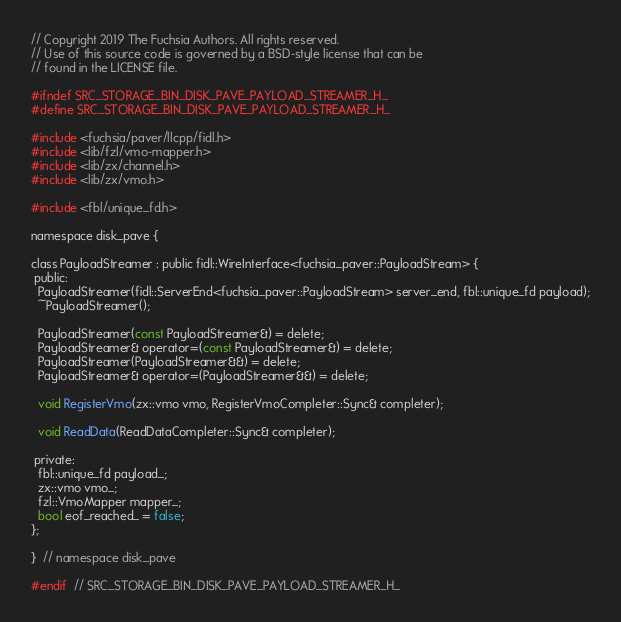<code> <loc_0><loc_0><loc_500><loc_500><_C_>// Copyright 2019 The Fuchsia Authors. All rights reserved.
// Use of this source code is governed by a BSD-style license that can be
// found in the LICENSE file.

#ifndef SRC_STORAGE_BIN_DISK_PAVE_PAYLOAD_STREAMER_H_
#define SRC_STORAGE_BIN_DISK_PAVE_PAYLOAD_STREAMER_H_

#include <fuchsia/paver/llcpp/fidl.h>
#include <lib/fzl/vmo-mapper.h>
#include <lib/zx/channel.h>
#include <lib/zx/vmo.h>

#include <fbl/unique_fd.h>

namespace disk_pave {

class PayloadStreamer : public fidl::WireInterface<fuchsia_paver::PayloadStream> {
 public:
  PayloadStreamer(fidl::ServerEnd<fuchsia_paver::PayloadStream> server_end, fbl::unique_fd payload);
  ~PayloadStreamer();

  PayloadStreamer(const PayloadStreamer&) = delete;
  PayloadStreamer& operator=(const PayloadStreamer&) = delete;
  PayloadStreamer(PayloadStreamer&&) = delete;
  PayloadStreamer& operator=(PayloadStreamer&&) = delete;

  void RegisterVmo(zx::vmo vmo, RegisterVmoCompleter::Sync& completer);

  void ReadData(ReadDataCompleter::Sync& completer);

 private:
  fbl::unique_fd payload_;
  zx::vmo vmo_;
  fzl::VmoMapper mapper_;
  bool eof_reached_ = false;
};

}  // namespace disk_pave

#endif  // SRC_STORAGE_BIN_DISK_PAVE_PAYLOAD_STREAMER_H_
</code> 